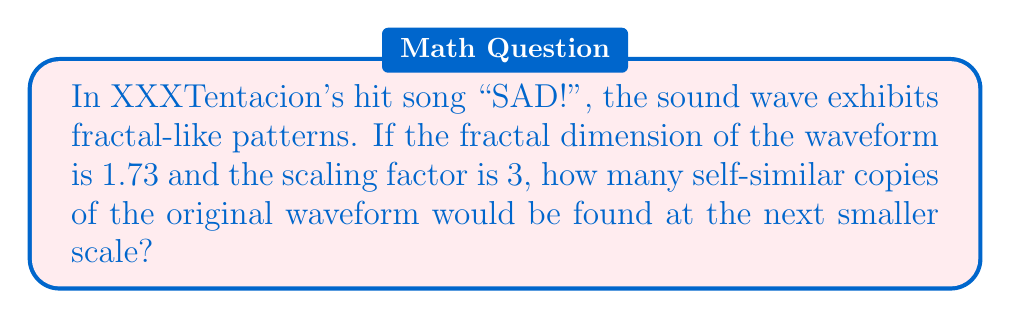Help me with this question. To solve this problem, we need to use the fundamental equation relating fractal dimension, scaling factor, and number of self-similar copies:

$$D = \frac{\log N}{\log r}$$

Where:
$D$ = Fractal dimension
$N$ = Number of self-similar copies
$r$ = Scaling factor

We are given:
$D = 1.73$
$r = 3$

Let's solve for $N$:

1) Substitute the known values into the equation:
   $$1.73 = \frac{\log N}{\log 3}$$

2) Multiply both sides by $\log 3$:
   $$1.73 \log 3 = \log N$$

3) Apply the exponential function to both sides:
   $$e^{1.73 \log 3} = e^{\log N}$$

4) Simplify the right side:
   $$e^{1.73 \log 3} = N$$

5) Calculate the left side:
   $$3^{1.73} = N$$

6) Evaluate:
   $$N \approx 5.98$$

7) Since we're dealing with discrete copies, we round to the nearest whole number:
   $$N = 6$$

Therefore, there would be 6 self-similar copies of the original waveform at the next smaller scale.
Answer: 6 self-similar copies 